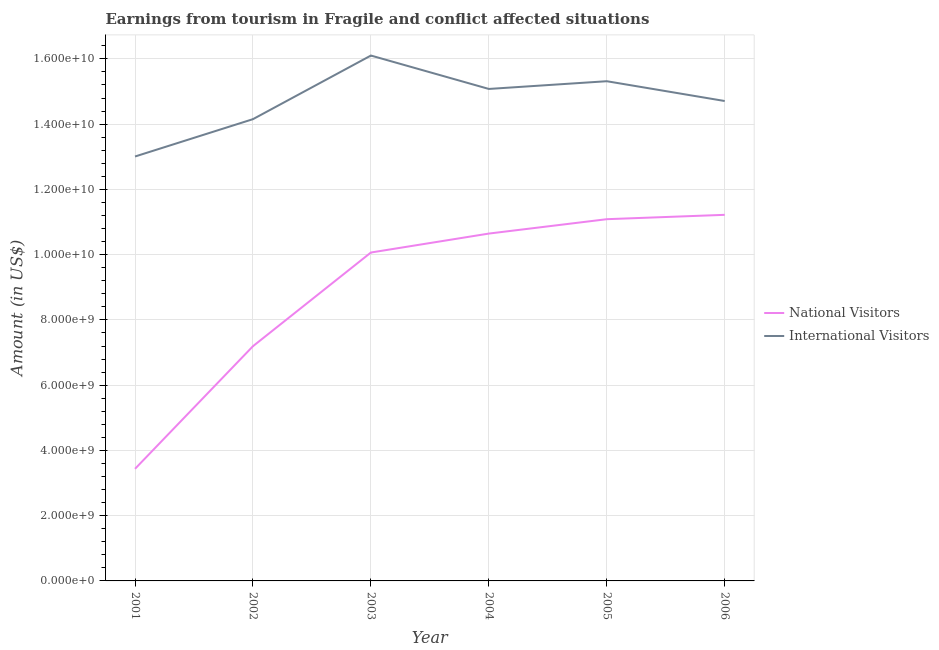How many different coloured lines are there?
Provide a succinct answer. 2. What is the amount earned from national visitors in 2006?
Offer a very short reply. 1.12e+1. Across all years, what is the maximum amount earned from national visitors?
Provide a short and direct response. 1.12e+1. Across all years, what is the minimum amount earned from international visitors?
Your response must be concise. 1.30e+1. In which year was the amount earned from international visitors minimum?
Offer a terse response. 2001. What is the total amount earned from international visitors in the graph?
Make the answer very short. 8.84e+1. What is the difference between the amount earned from national visitors in 2002 and that in 2005?
Provide a succinct answer. -3.89e+09. What is the difference between the amount earned from international visitors in 2003 and the amount earned from national visitors in 2006?
Your answer should be compact. 4.88e+09. What is the average amount earned from national visitors per year?
Offer a very short reply. 8.94e+09. In the year 2001, what is the difference between the amount earned from national visitors and amount earned from international visitors?
Make the answer very short. -9.57e+09. What is the ratio of the amount earned from national visitors in 2002 to that in 2004?
Give a very brief answer. 0.68. Is the amount earned from international visitors in 2001 less than that in 2005?
Make the answer very short. Yes. What is the difference between the highest and the second highest amount earned from international visitors?
Ensure brevity in your answer.  7.87e+08. What is the difference between the highest and the lowest amount earned from national visitors?
Offer a terse response. 7.79e+09. In how many years, is the amount earned from national visitors greater than the average amount earned from national visitors taken over all years?
Your response must be concise. 4. Is the amount earned from international visitors strictly greater than the amount earned from national visitors over the years?
Your response must be concise. Yes. How many lines are there?
Your response must be concise. 2. How many years are there in the graph?
Provide a succinct answer. 6. Does the graph contain any zero values?
Keep it short and to the point. No. How many legend labels are there?
Your answer should be very brief. 2. What is the title of the graph?
Your answer should be very brief. Earnings from tourism in Fragile and conflict affected situations. Does "Taxes on profits and capital gains" appear as one of the legend labels in the graph?
Your answer should be very brief. No. What is the label or title of the Y-axis?
Provide a succinct answer. Amount (in US$). What is the Amount (in US$) in National Visitors in 2001?
Your answer should be compact. 3.44e+09. What is the Amount (in US$) in International Visitors in 2001?
Your answer should be compact. 1.30e+1. What is the Amount (in US$) of National Visitors in 2002?
Offer a terse response. 7.19e+09. What is the Amount (in US$) in International Visitors in 2002?
Provide a succinct answer. 1.42e+1. What is the Amount (in US$) in National Visitors in 2003?
Provide a short and direct response. 1.01e+1. What is the Amount (in US$) in International Visitors in 2003?
Provide a short and direct response. 1.61e+1. What is the Amount (in US$) in National Visitors in 2004?
Give a very brief answer. 1.06e+1. What is the Amount (in US$) in International Visitors in 2004?
Provide a succinct answer. 1.51e+1. What is the Amount (in US$) in National Visitors in 2005?
Keep it short and to the point. 1.11e+1. What is the Amount (in US$) in International Visitors in 2005?
Ensure brevity in your answer.  1.53e+1. What is the Amount (in US$) in National Visitors in 2006?
Your response must be concise. 1.12e+1. What is the Amount (in US$) of International Visitors in 2006?
Ensure brevity in your answer.  1.47e+1. Across all years, what is the maximum Amount (in US$) in National Visitors?
Make the answer very short. 1.12e+1. Across all years, what is the maximum Amount (in US$) in International Visitors?
Your answer should be compact. 1.61e+1. Across all years, what is the minimum Amount (in US$) in National Visitors?
Keep it short and to the point. 3.44e+09. Across all years, what is the minimum Amount (in US$) in International Visitors?
Keep it short and to the point. 1.30e+1. What is the total Amount (in US$) in National Visitors in the graph?
Keep it short and to the point. 5.36e+1. What is the total Amount (in US$) of International Visitors in the graph?
Your response must be concise. 8.84e+1. What is the difference between the Amount (in US$) of National Visitors in 2001 and that in 2002?
Offer a very short reply. -3.76e+09. What is the difference between the Amount (in US$) of International Visitors in 2001 and that in 2002?
Provide a succinct answer. -1.14e+09. What is the difference between the Amount (in US$) of National Visitors in 2001 and that in 2003?
Ensure brevity in your answer.  -6.63e+09. What is the difference between the Amount (in US$) in International Visitors in 2001 and that in 2003?
Offer a terse response. -3.09e+09. What is the difference between the Amount (in US$) of National Visitors in 2001 and that in 2004?
Provide a short and direct response. -7.21e+09. What is the difference between the Amount (in US$) in International Visitors in 2001 and that in 2004?
Make the answer very short. -2.07e+09. What is the difference between the Amount (in US$) in National Visitors in 2001 and that in 2005?
Your answer should be compact. -7.65e+09. What is the difference between the Amount (in US$) of International Visitors in 2001 and that in 2005?
Your answer should be compact. -2.31e+09. What is the difference between the Amount (in US$) in National Visitors in 2001 and that in 2006?
Provide a short and direct response. -7.79e+09. What is the difference between the Amount (in US$) of International Visitors in 2001 and that in 2006?
Ensure brevity in your answer.  -1.70e+09. What is the difference between the Amount (in US$) of National Visitors in 2002 and that in 2003?
Give a very brief answer. -2.87e+09. What is the difference between the Amount (in US$) of International Visitors in 2002 and that in 2003?
Offer a terse response. -1.95e+09. What is the difference between the Amount (in US$) in National Visitors in 2002 and that in 2004?
Your response must be concise. -3.45e+09. What is the difference between the Amount (in US$) of International Visitors in 2002 and that in 2004?
Your response must be concise. -9.26e+08. What is the difference between the Amount (in US$) of National Visitors in 2002 and that in 2005?
Offer a very short reply. -3.89e+09. What is the difference between the Amount (in US$) of International Visitors in 2002 and that in 2005?
Provide a succinct answer. -1.16e+09. What is the difference between the Amount (in US$) in National Visitors in 2002 and that in 2006?
Your response must be concise. -4.03e+09. What is the difference between the Amount (in US$) in International Visitors in 2002 and that in 2006?
Offer a very short reply. -5.56e+08. What is the difference between the Amount (in US$) in National Visitors in 2003 and that in 2004?
Your answer should be very brief. -5.81e+08. What is the difference between the Amount (in US$) of International Visitors in 2003 and that in 2004?
Give a very brief answer. 1.02e+09. What is the difference between the Amount (in US$) in National Visitors in 2003 and that in 2005?
Give a very brief answer. -1.02e+09. What is the difference between the Amount (in US$) in International Visitors in 2003 and that in 2005?
Ensure brevity in your answer.  7.87e+08. What is the difference between the Amount (in US$) in National Visitors in 2003 and that in 2006?
Provide a short and direct response. -1.16e+09. What is the difference between the Amount (in US$) of International Visitors in 2003 and that in 2006?
Ensure brevity in your answer.  1.39e+09. What is the difference between the Amount (in US$) of National Visitors in 2004 and that in 2005?
Provide a short and direct response. -4.41e+08. What is the difference between the Amount (in US$) in International Visitors in 2004 and that in 2005?
Your answer should be compact. -2.37e+08. What is the difference between the Amount (in US$) in National Visitors in 2004 and that in 2006?
Ensure brevity in your answer.  -5.75e+08. What is the difference between the Amount (in US$) of International Visitors in 2004 and that in 2006?
Keep it short and to the point. 3.70e+08. What is the difference between the Amount (in US$) in National Visitors in 2005 and that in 2006?
Keep it short and to the point. -1.34e+08. What is the difference between the Amount (in US$) in International Visitors in 2005 and that in 2006?
Offer a terse response. 6.07e+08. What is the difference between the Amount (in US$) of National Visitors in 2001 and the Amount (in US$) of International Visitors in 2002?
Offer a very short reply. -1.07e+1. What is the difference between the Amount (in US$) in National Visitors in 2001 and the Amount (in US$) in International Visitors in 2003?
Keep it short and to the point. -1.27e+1. What is the difference between the Amount (in US$) of National Visitors in 2001 and the Amount (in US$) of International Visitors in 2004?
Ensure brevity in your answer.  -1.16e+1. What is the difference between the Amount (in US$) of National Visitors in 2001 and the Amount (in US$) of International Visitors in 2005?
Provide a short and direct response. -1.19e+1. What is the difference between the Amount (in US$) in National Visitors in 2001 and the Amount (in US$) in International Visitors in 2006?
Offer a very short reply. -1.13e+1. What is the difference between the Amount (in US$) in National Visitors in 2002 and the Amount (in US$) in International Visitors in 2003?
Offer a terse response. -8.91e+09. What is the difference between the Amount (in US$) in National Visitors in 2002 and the Amount (in US$) in International Visitors in 2004?
Provide a short and direct response. -7.88e+09. What is the difference between the Amount (in US$) of National Visitors in 2002 and the Amount (in US$) of International Visitors in 2005?
Offer a terse response. -8.12e+09. What is the difference between the Amount (in US$) of National Visitors in 2002 and the Amount (in US$) of International Visitors in 2006?
Your answer should be very brief. -7.51e+09. What is the difference between the Amount (in US$) of National Visitors in 2003 and the Amount (in US$) of International Visitors in 2004?
Offer a terse response. -5.01e+09. What is the difference between the Amount (in US$) in National Visitors in 2003 and the Amount (in US$) in International Visitors in 2005?
Your response must be concise. -5.25e+09. What is the difference between the Amount (in US$) in National Visitors in 2003 and the Amount (in US$) in International Visitors in 2006?
Provide a succinct answer. -4.64e+09. What is the difference between the Amount (in US$) in National Visitors in 2004 and the Amount (in US$) in International Visitors in 2005?
Keep it short and to the point. -4.67e+09. What is the difference between the Amount (in US$) in National Visitors in 2004 and the Amount (in US$) in International Visitors in 2006?
Provide a succinct answer. -4.06e+09. What is the difference between the Amount (in US$) of National Visitors in 2005 and the Amount (in US$) of International Visitors in 2006?
Make the answer very short. -3.62e+09. What is the average Amount (in US$) in National Visitors per year?
Give a very brief answer. 8.94e+09. What is the average Amount (in US$) in International Visitors per year?
Make the answer very short. 1.47e+1. In the year 2001, what is the difference between the Amount (in US$) of National Visitors and Amount (in US$) of International Visitors?
Offer a very short reply. -9.57e+09. In the year 2002, what is the difference between the Amount (in US$) of National Visitors and Amount (in US$) of International Visitors?
Provide a succinct answer. -6.96e+09. In the year 2003, what is the difference between the Amount (in US$) of National Visitors and Amount (in US$) of International Visitors?
Your answer should be very brief. -6.04e+09. In the year 2004, what is the difference between the Amount (in US$) of National Visitors and Amount (in US$) of International Visitors?
Offer a very short reply. -4.43e+09. In the year 2005, what is the difference between the Amount (in US$) of National Visitors and Amount (in US$) of International Visitors?
Your answer should be compact. -4.23e+09. In the year 2006, what is the difference between the Amount (in US$) in National Visitors and Amount (in US$) in International Visitors?
Give a very brief answer. -3.49e+09. What is the ratio of the Amount (in US$) of National Visitors in 2001 to that in 2002?
Your answer should be very brief. 0.48. What is the ratio of the Amount (in US$) in International Visitors in 2001 to that in 2002?
Your response must be concise. 0.92. What is the ratio of the Amount (in US$) of National Visitors in 2001 to that in 2003?
Your answer should be very brief. 0.34. What is the ratio of the Amount (in US$) in International Visitors in 2001 to that in 2003?
Ensure brevity in your answer.  0.81. What is the ratio of the Amount (in US$) in National Visitors in 2001 to that in 2004?
Ensure brevity in your answer.  0.32. What is the ratio of the Amount (in US$) in International Visitors in 2001 to that in 2004?
Your answer should be compact. 0.86. What is the ratio of the Amount (in US$) in National Visitors in 2001 to that in 2005?
Your answer should be very brief. 0.31. What is the ratio of the Amount (in US$) of International Visitors in 2001 to that in 2005?
Your answer should be compact. 0.85. What is the ratio of the Amount (in US$) in National Visitors in 2001 to that in 2006?
Keep it short and to the point. 0.31. What is the ratio of the Amount (in US$) of International Visitors in 2001 to that in 2006?
Your answer should be compact. 0.88. What is the ratio of the Amount (in US$) in National Visitors in 2002 to that in 2003?
Provide a short and direct response. 0.71. What is the ratio of the Amount (in US$) in International Visitors in 2002 to that in 2003?
Provide a short and direct response. 0.88. What is the ratio of the Amount (in US$) in National Visitors in 2002 to that in 2004?
Provide a succinct answer. 0.68. What is the ratio of the Amount (in US$) in International Visitors in 2002 to that in 2004?
Provide a short and direct response. 0.94. What is the ratio of the Amount (in US$) of National Visitors in 2002 to that in 2005?
Offer a terse response. 0.65. What is the ratio of the Amount (in US$) in International Visitors in 2002 to that in 2005?
Ensure brevity in your answer.  0.92. What is the ratio of the Amount (in US$) in National Visitors in 2002 to that in 2006?
Your answer should be compact. 0.64. What is the ratio of the Amount (in US$) of International Visitors in 2002 to that in 2006?
Offer a very short reply. 0.96. What is the ratio of the Amount (in US$) of National Visitors in 2003 to that in 2004?
Ensure brevity in your answer.  0.95. What is the ratio of the Amount (in US$) of International Visitors in 2003 to that in 2004?
Keep it short and to the point. 1.07. What is the ratio of the Amount (in US$) in National Visitors in 2003 to that in 2005?
Offer a very short reply. 0.91. What is the ratio of the Amount (in US$) of International Visitors in 2003 to that in 2005?
Your answer should be compact. 1.05. What is the ratio of the Amount (in US$) in National Visitors in 2003 to that in 2006?
Keep it short and to the point. 0.9. What is the ratio of the Amount (in US$) of International Visitors in 2003 to that in 2006?
Offer a terse response. 1.09. What is the ratio of the Amount (in US$) of National Visitors in 2004 to that in 2005?
Provide a short and direct response. 0.96. What is the ratio of the Amount (in US$) in International Visitors in 2004 to that in 2005?
Provide a short and direct response. 0.98. What is the ratio of the Amount (in US$) in National Visitors in 2004 to that in 2006?
Your response must be concise. 0.95. What is the ratio of the Amount (in US$) in International Visitors in 2004 to that in 2006?
Keep it short and to the point. 1.03. What is the ratio of the Amount (in US$) in International Visitors in 2005 to that in 2006?
Offer a very short reply. 1.04. What is the difference between the highest and the second highest Amount (in US$) in National Visitors?
Offer a very short reply. 1.34e+08. What is the difference between the highest and the second highest Amount (in US$) of International Visitors?
Provide a short and direct response. 7.87e+08. What is the difference between the highest and the lowest Amount (in US$) of National Visitors?
Your answer should be compact. 7.79e+09. What is the difference between the highest and the lowest Amount (in US$) in International Visitors?
Your answer should be very brief. 3.09e+09. 